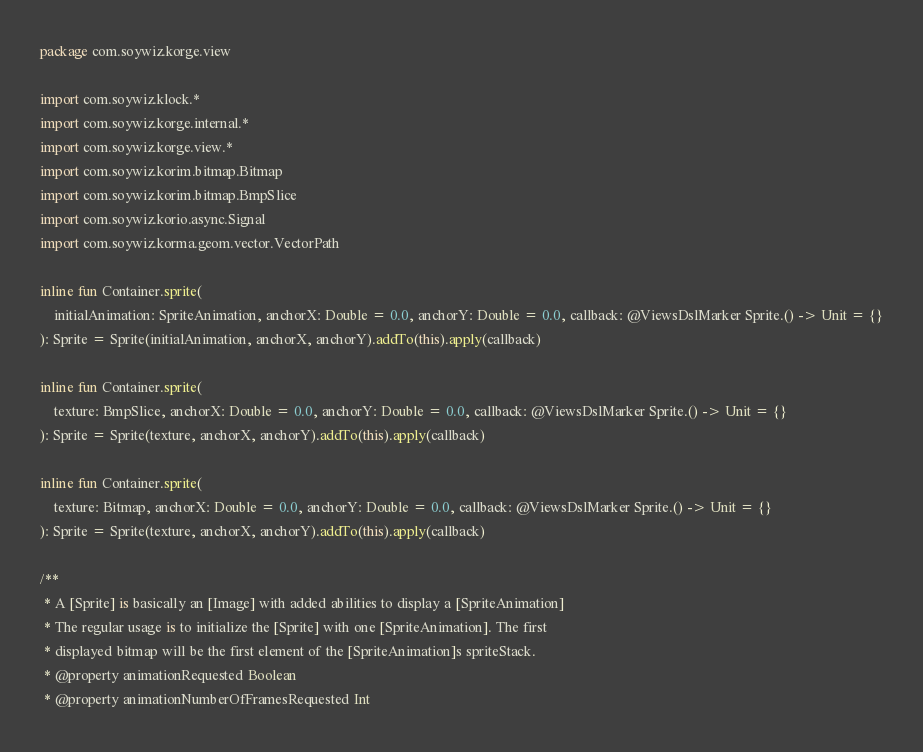Convert code to text. <code><loc_0><loc_0><loc_500><loc_500><_Kotlin_>package com.soywiz.korge.view

import com.soywiz.klock.*
import com.soywiz.korge.internal.*
import com.soywiz.korge.view.*
import com.soywiz.korim.bitmap.Bitmap
import com.soywiz.korim.bitmap.BmpSlice
import com.soywiz.korio.async.Signal
import com.soywiz.korma.geom.vector.VectorPath

inline fun Container.sprite(
    initialAnimation: SpriteAnimation, anchorX: Double = 0.0, anchorY: Double = 0.0, callback: @ViewsDslMarker Sprite.() -> Unit = {}
): Sprite = Sprite(initialAnimation, anchorX, anchorY).addTo(this).apply(callback)

inline fun Container.sprite(
    texture: BmpSlice, anchorX: Double = 0.0, anchorY: Double = 0.0, callback: @ViewsDslMarker Sprite.() -> Unit = {}
): Sprite = Sprite(texture, anchorX, anchorY).addTo(this).apply(callback)

inline fun Container.sprite(
    texture: Bitmap, anchorX: Double = 0.0, anchorY: Double = 0.0, callback: @ViewsDslMarker Sprite.() -> Unit = {}
): Sprite = Sprite(texture, anchorX, anchorY).addTo(this).apply(callback)

/**
 * A [Sprite] is basically an [Image] with added abilities to display a [SpriteAnimation]
 * The regular usage is to initialize the [Sprite] with one [SpriteAnimation]. The first
 * displayed bitmap will be the first element of the [SpriteAnimation]s spriteStack.
 * @property animationRequested Boolean
 * @property animationNumberOfFramesRequested Int</code> 